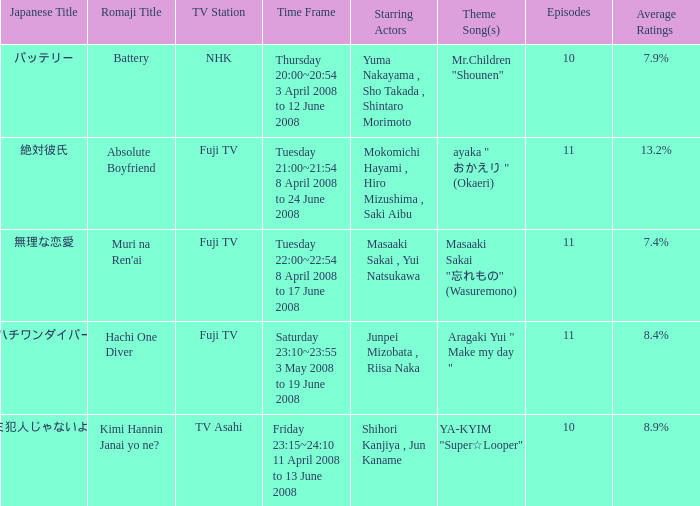Who were the starting actors in the time frame of  tuesday 22:00~22:54 8 april 2008 to 17 june 2008? Masaaki Sakai , Yui Natsukawa. 